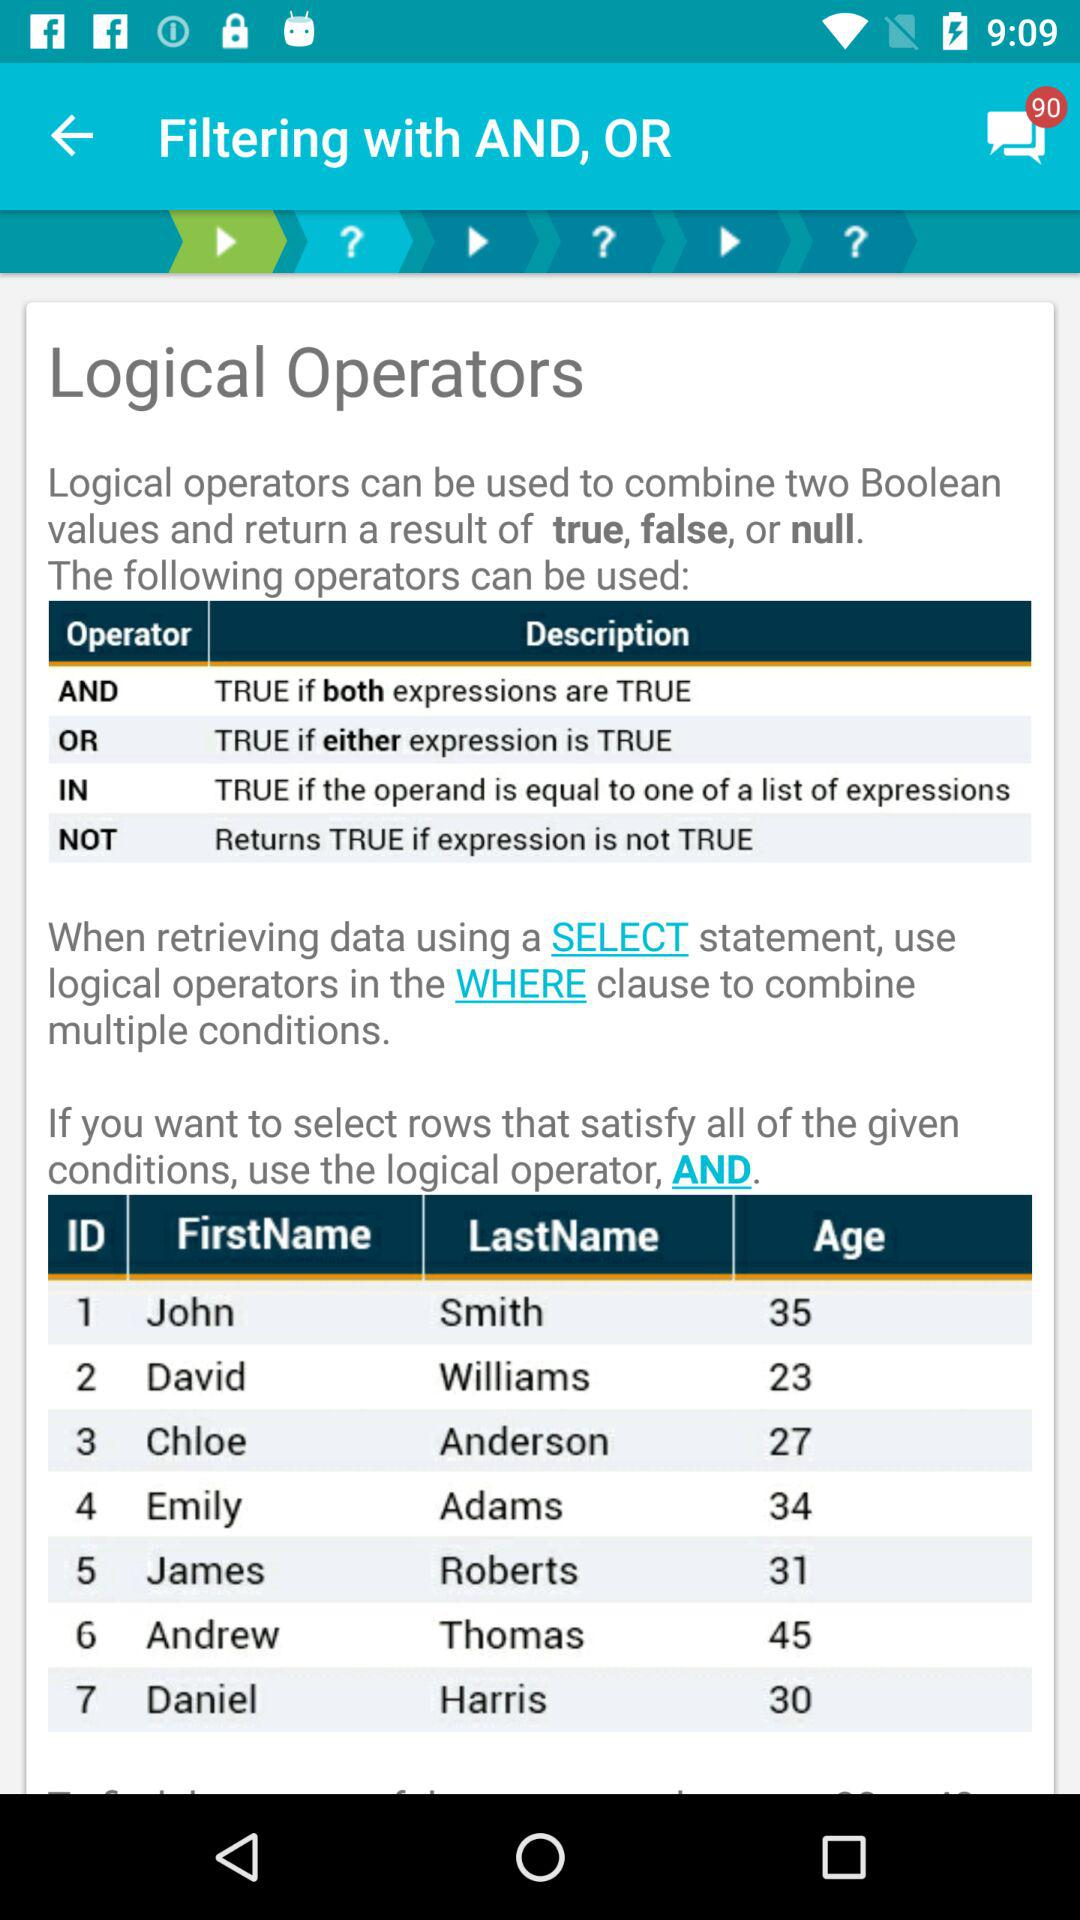What is the description of the "AND" operator? The description of the "AND" operator is "TRUE if both expressions are TRUE". 